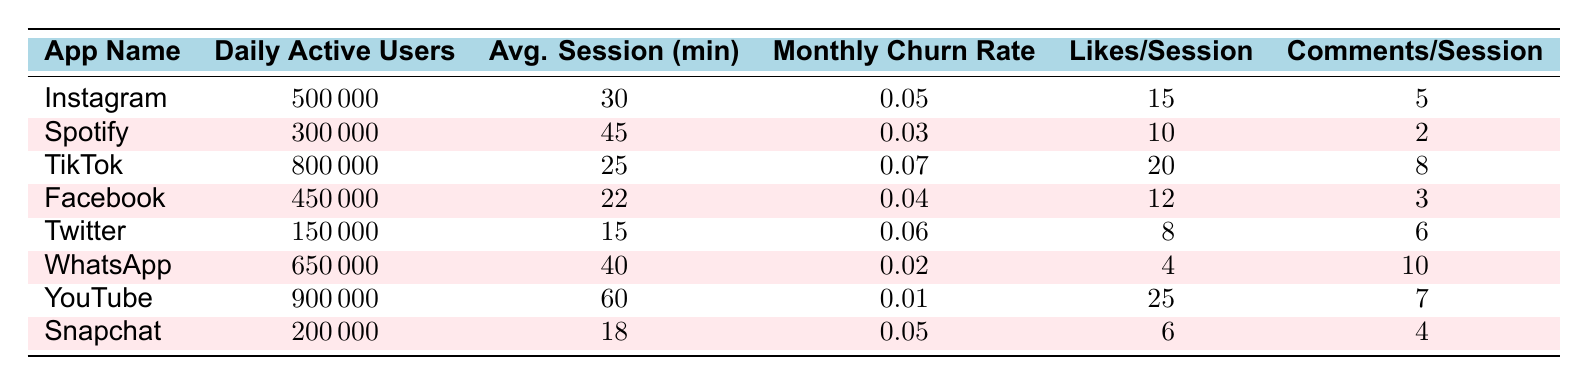What's the Daily Active Users for WhatsApp? The table shows that the Daily Active Users for WhatsApp is listed as 650,000.
Answer: 650000 Which app has the highest Average Session Duration? By comparing the Average Session Duration values in the table, YouTube has the highest at 60 minutes.
Answer: YouTube What is the Monthly Churn Rate for TikTok? The Monthly Churn Rate for TikTok is listed as 0.07 in the table.
Answer: 0.07 Which app has the lowest number of Daily Active Users? Looking at the Daily Active Users column, Twitter has the lowest value at 150,000.
Answer: Twitter How many Likes per Session does Instagram have? The table indicates that Instagram has 15 Likes per Session.
Answer: 15 Which app has a higher Monthly Churn Rate, Instagram or Facebook? The Monthly Churn Rate for Instagram is 0.05, and for Facebook, it is 0.04. Since 0.05 is greater than 0.04, Instagram has a higher rate.
Answer: Instagram What is the total number of Daily Active Users for all apps listed? We sum the Daily Active Users for each app: 500,000 (Instagram) + 300,000 (Spotify) + 800,000 (TikTok) + 450,000 (Facebook) + 150,000 (Twitter) + 650,000 (WhatsApp) + 900,000 (YouTube) + 200,000 (Snapchat) = 3,950,000.
Answer: 3950000 How many Likes per Session do users average on TikTok compared to Spotify? TikTok has 20 Likes per Session, and Spotify has 10. Comparing these, TikTok has twice as many Likes per Session as Spotify.
Answer: TikTok has more Is the Average Session Duration for Snapchat longer than that of Facebook? Snapchat has an Average Session Duration of 18 minutes, while Facebook has 22 minutes. Since 18 is less than 22, Snapchat's duration is shorter.
Answer: No What is the average Monthly Churn Rate of the apps listed? We sum the Monthly Churn Rates: 0.05 + 0.03 + 0.07 + 0.04 + 0.06 + 0.02 + 0.01 + 0.05 = 0.33. There are 8 apps, so we divide 0.33 by 8 to get 0.04125, which rounds to 0.041.
Answer: 0.041 Which app has the most Comments per Session? In the table, YouTube with 7 Comments per Session has more than all other apps listed when compared by their values.
Answer: WhatsApp 